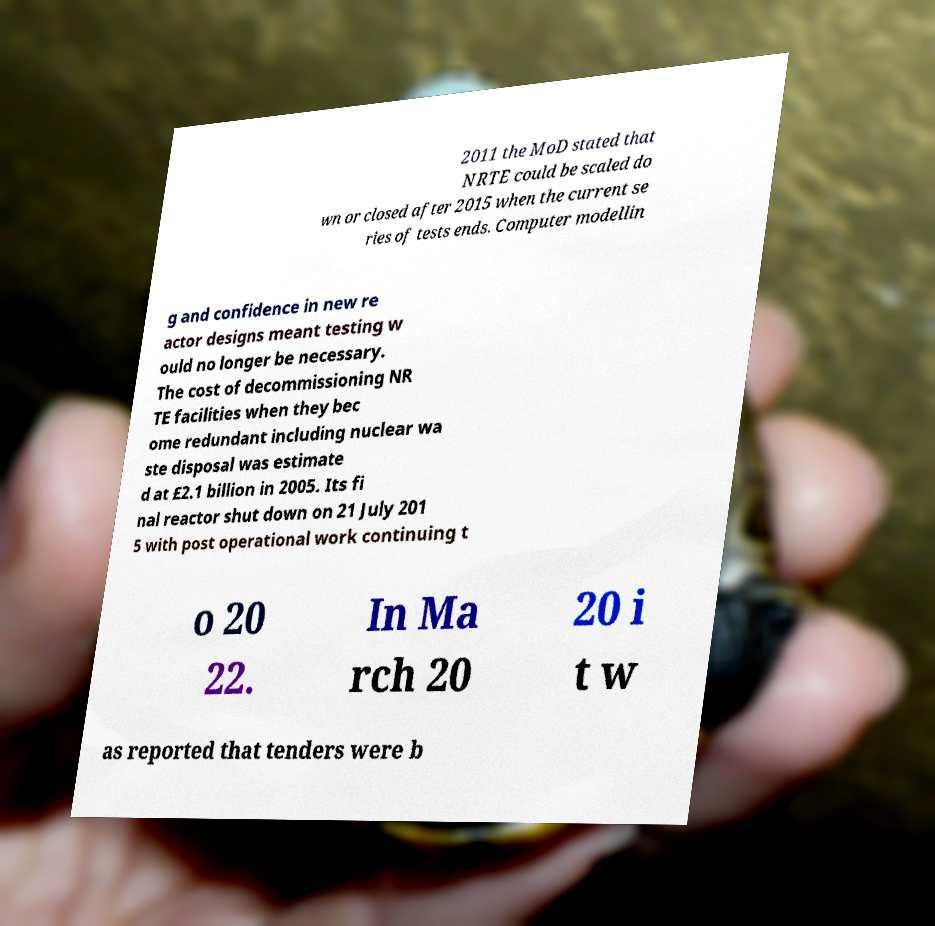I need the written content from this picture converted into text. Can you do that? 2011 the MoD stated that NRTE could be scaled do wn or closed after 2015 when the current se ries of tests ends. Computer modellin g and confidence in new re actor designs meant testing w ould no longer be necessary. The cost of decommissioning NR TE facilities when they bec ome redundant including nuclear wa ste disposal was estimate d at £2.1 billion in 2005. Its fi nal reactor shut down on 21 July 201 5 with post operational work continuing t o 20 22. In Ma rch 20 20 i t w as reported that tenders were b 